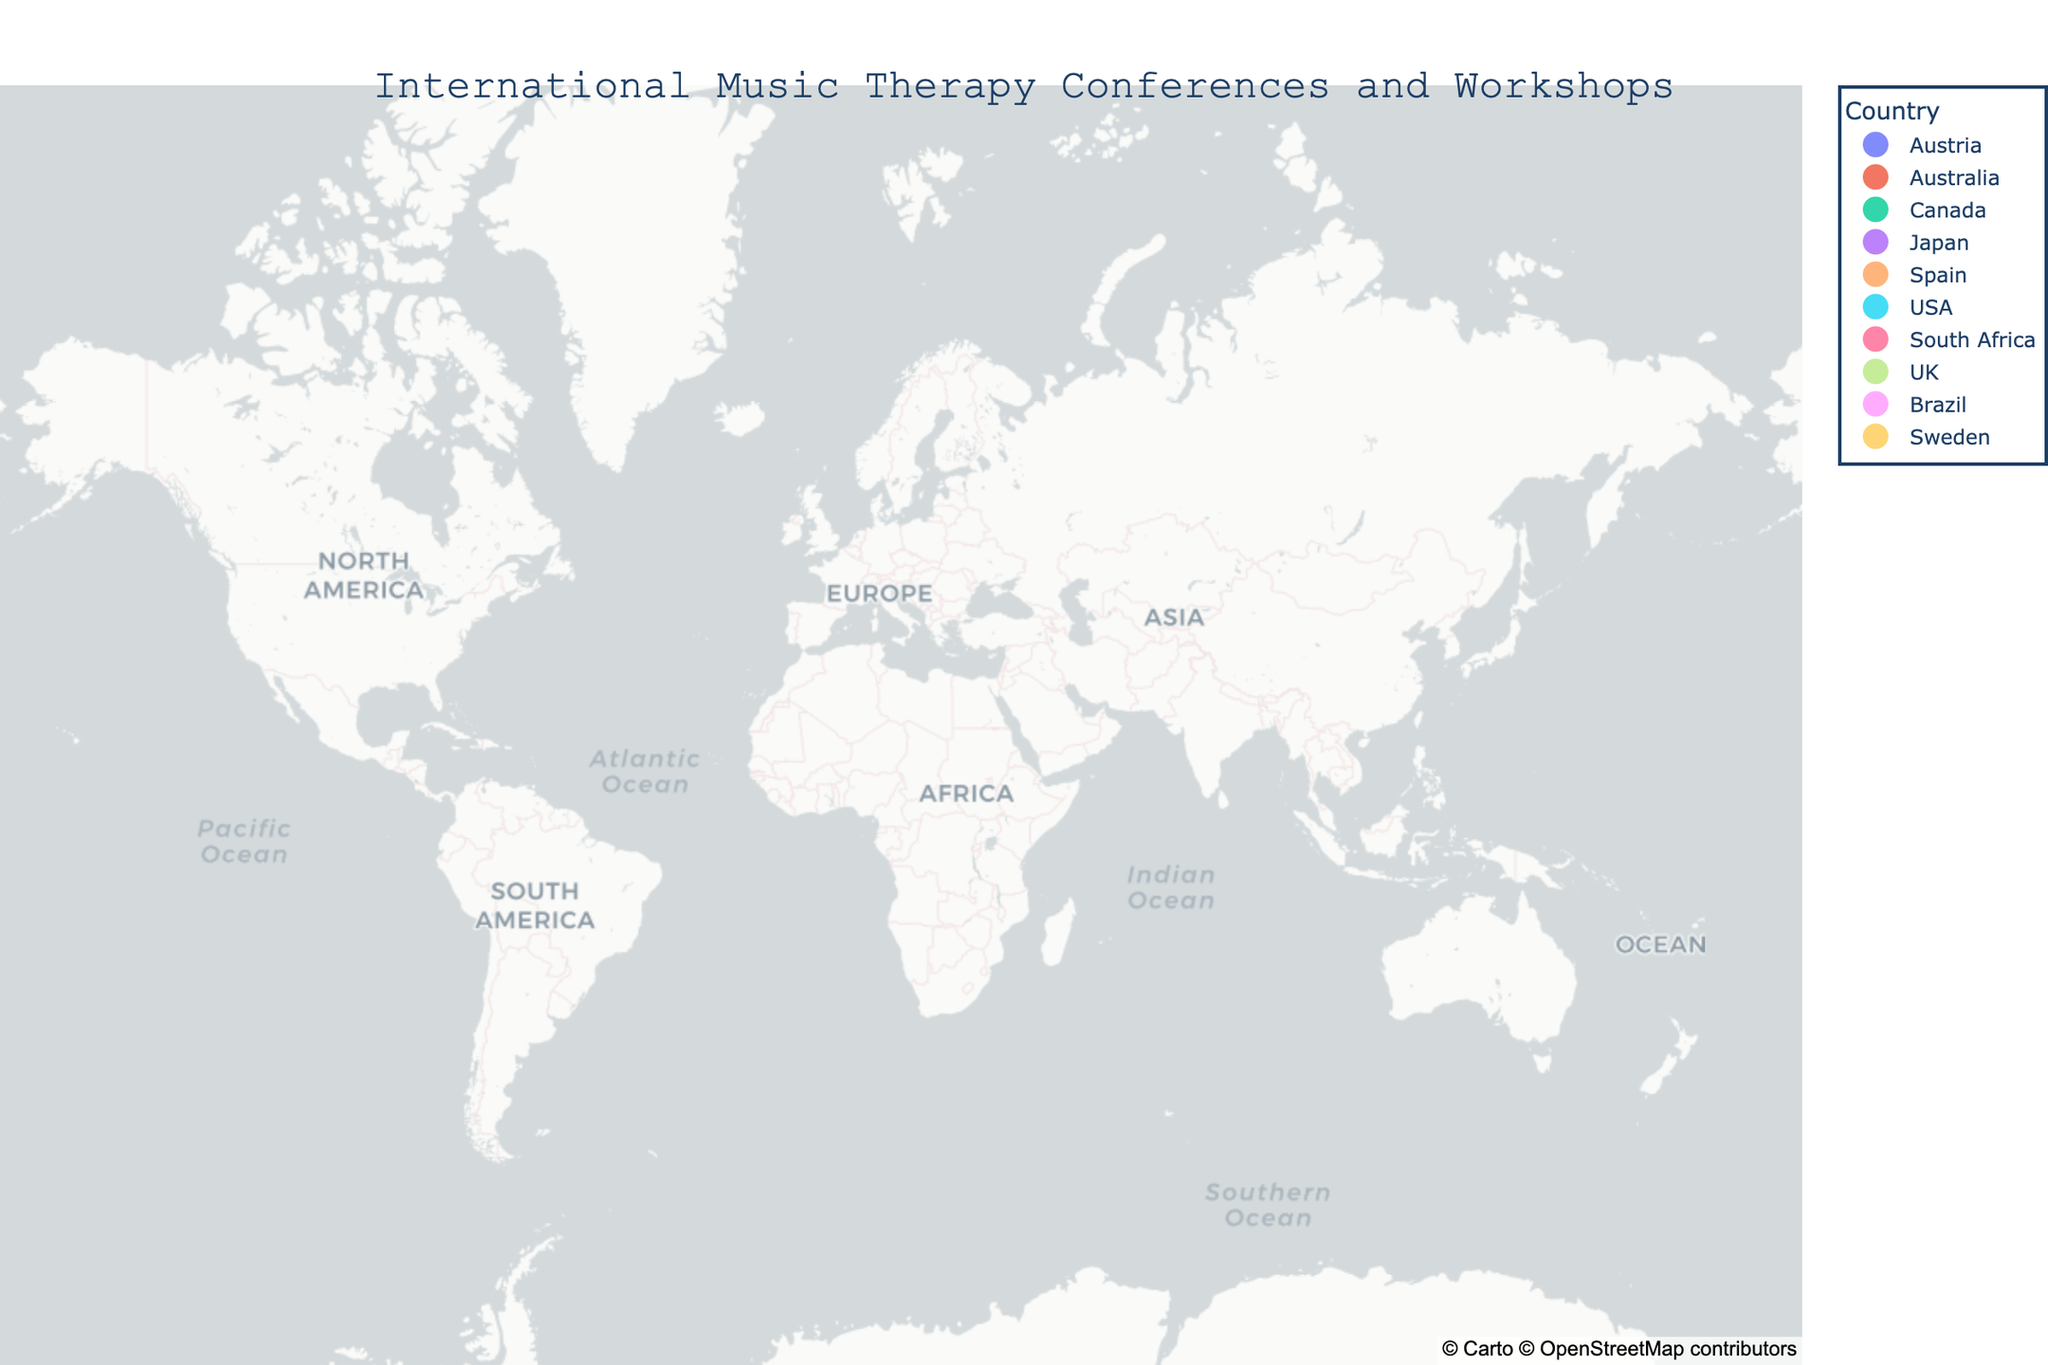What is the title of the map? The title of the map is prominently displayed at the center-top of the figure in a large font.
Answer: International Music Therapy Conferences and Workshops Which city hosts the Canadian Association for Music Therapy Conference? By looking at the hover information on the map, you can find the city associated with the Canadian conference. The data points will highlight relevant details as you hover over the location.
Answer: Toronto How many conferences are there in Europe? By hovering over the data points in European countries, you can count the number of conferences hosted in Europe.
Answer: 3 Are there any music therapy conferences in Africa? You can identify the continent of Africa on the map and check if there are any data points present. Hovering over these points gives more details.
Answer: Yes, in Cape Town Which conference is located furthest south? By comparing the latitude values of all the conference locations, the southernmost latitude can be identified.
Answer: World Congress of Music Therapy in Melbourne Which country has the most music therapy conferences listed? By observing the color legend and looking for the country that is marked most frequently on the map, we can determine the answer.
Answer: USA What is the latitude and longitude of the International Cello and Music Therapy Workshop? By finding the specific workshop location on the map and referring to its hover information, the exact coordinates can be revealed.
Answer: 41.3851, 2.1734 Are there more conferences located in the Northern Hemisphere or the Southern Hemisphere? The equator divides the Northern and Southern Hemispheres. By counting the conferences above and below the equator on the map, we can determine the distribution.
Answer: More in the Northern Hemisphere Which conference is closest to the Prime Meridian? The Prime Meridian is at 0° longitude. Checking the longitudes of all conferences, the closest one can be identified.
Answer: British Association for Music Therapy Symposium in London How many continents are represented in the map? By observing the locations of the conferences on the map, we can count the number of continents represented.
Answer: 6 